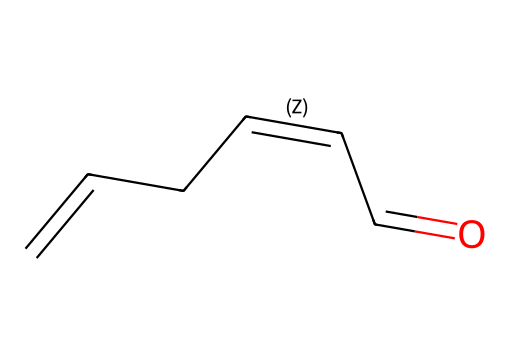What is the total number of carbon atoms in this compound? By analyzing the SMILES representation, we can count the number of carbon atoms: there are six "C" characters in the string, indicating six carbon atoms.
Answer: six What type of functional group is present in this compound? The presence of the "C=O" in the SMILES indicates a carbonyl group, which is characteristic of aldehydes or ketones. Given the structure, it is an aldehyde functional group.
Answer: aldehyde How many double bonds are there in the molecular structure? In the SMILES representation, we can count two double bonds: one in "C=CC" and one in "C=C". Therefore, the total number of double bonds is two.
Answer: two What is the degree of unsaturation of this organic compound? The degree of unsaturation can be calculated from the formula: (2C + 2 + N - H - X)/2. Here, C=6, H=8 (based on valences), giving us a degree of unsaturation of 3.
Answer: three Is this compound likely to be polar or nonpolar? The presence of the carbonyl group (C=O) introduces polarity to the molecule, making it more likely to be polar due to the electronegative oxygen atom.
Answer: polar What is the common name for this compound, often associated with its scent? This compound is known as "green leaf volatile" (GLV), which is released when grass is cut and is responsible for the fresh-cut grass smell.
Answer: green leaf volatile 